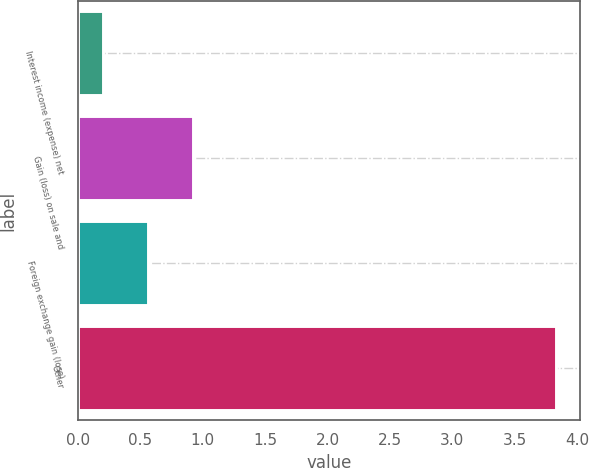Convert chart. <chart><loc_0><loc_0><loc_500><loc_500><bar_chart><fcel>Interest income (expense) net<fcel>Gain (loss) on sale and<fcel>Foreign exchange gain (loss)<fcel>Other<nl><fcel>0.2<fcel>0.92<fcel>0.56<fcel>3.83<nl></chart> 